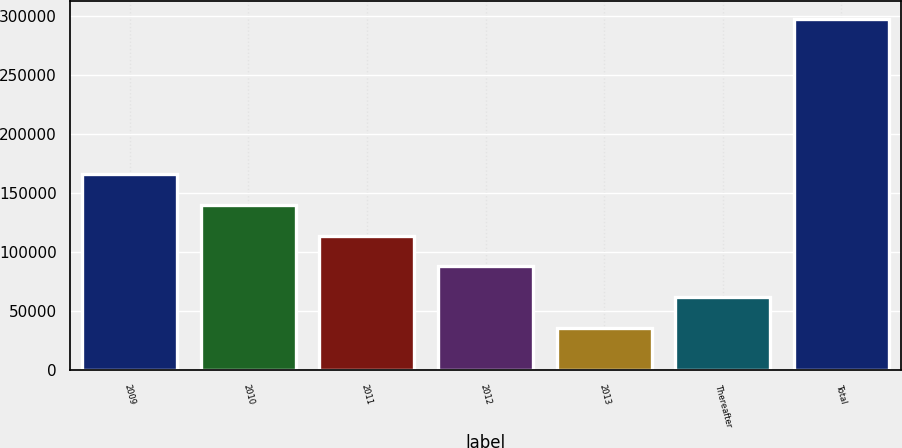Convert chart to OTSL. <chart><loc_0><loc_0><loc_500><loc_500><bar_chart><fcel>2009<fcel>2010<fcel>2011<fcel>2012<fcel>2013<fcel>Thereafter<fcel>Total<nl><fcel>166653<fcel>140428<fcel>114203<fcel>87978<fcel>35528<fcel>61753<fcel>297778<nl></chart> 